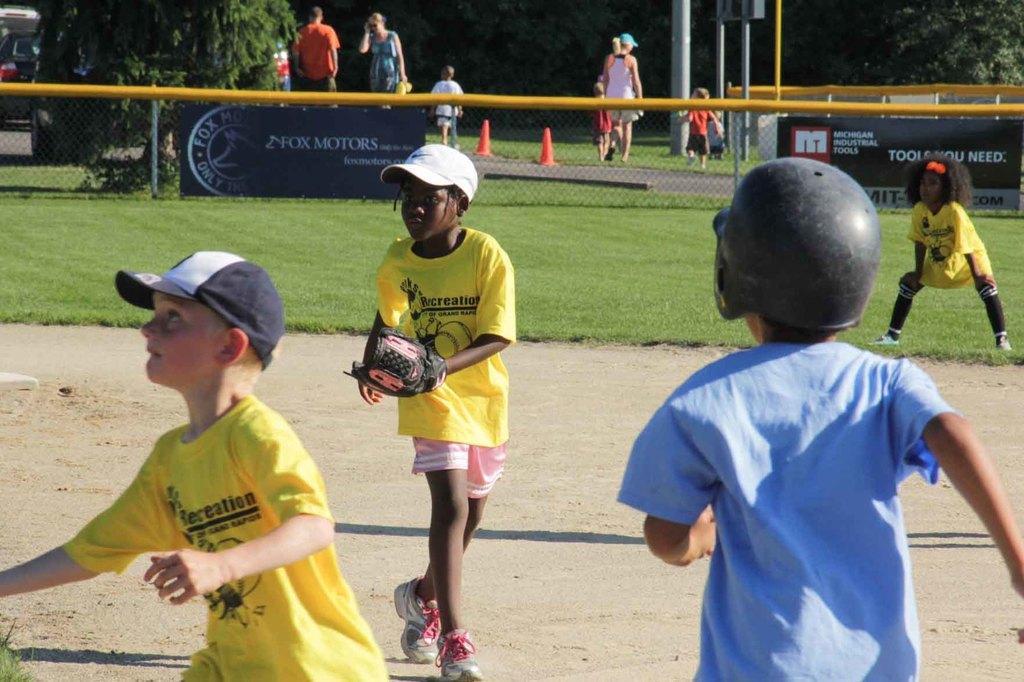Describe this image in one or two sentences. This picture shows few kids playing and we see three boys and a girl. They wore caps on their heads and a boy wore glove to his hand and we see trees and few people walking on the side and we see grass on the ground and few poles on the sidewalk. 